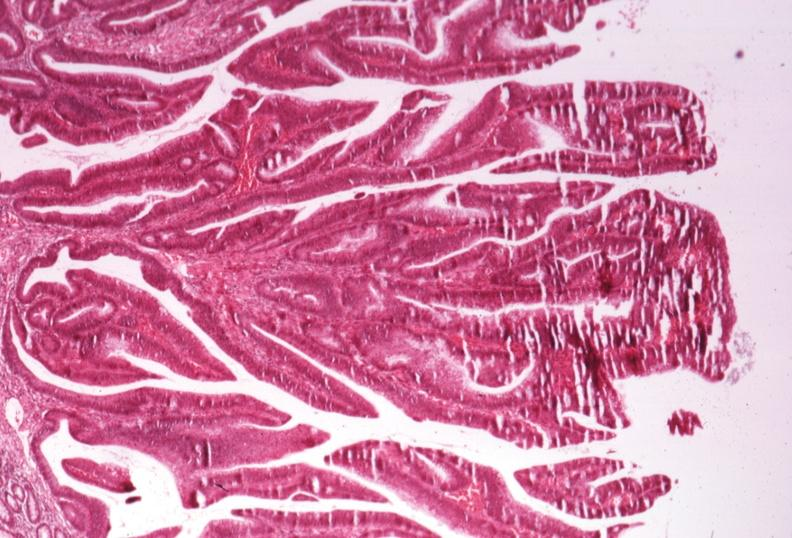what is present?
Answer the question using a single word or phrase. Gastrointestinal 